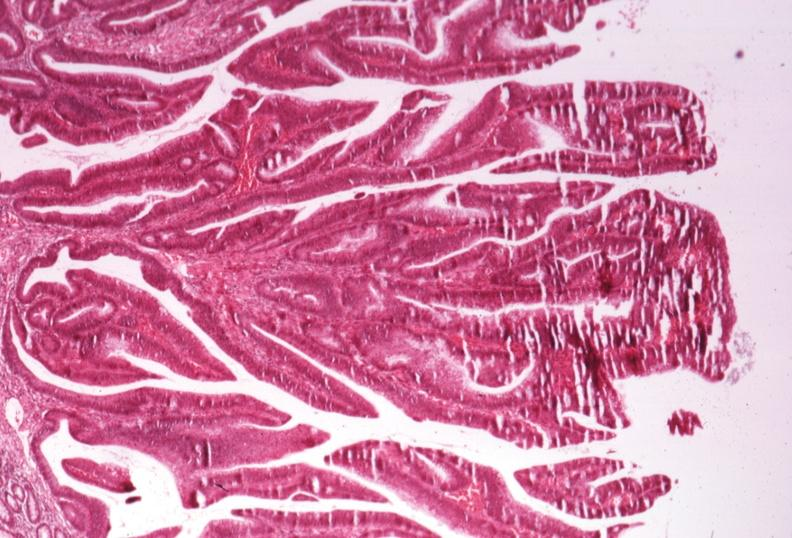what is present?
Answer the question using a single word or phrase. Gastrointestinal 